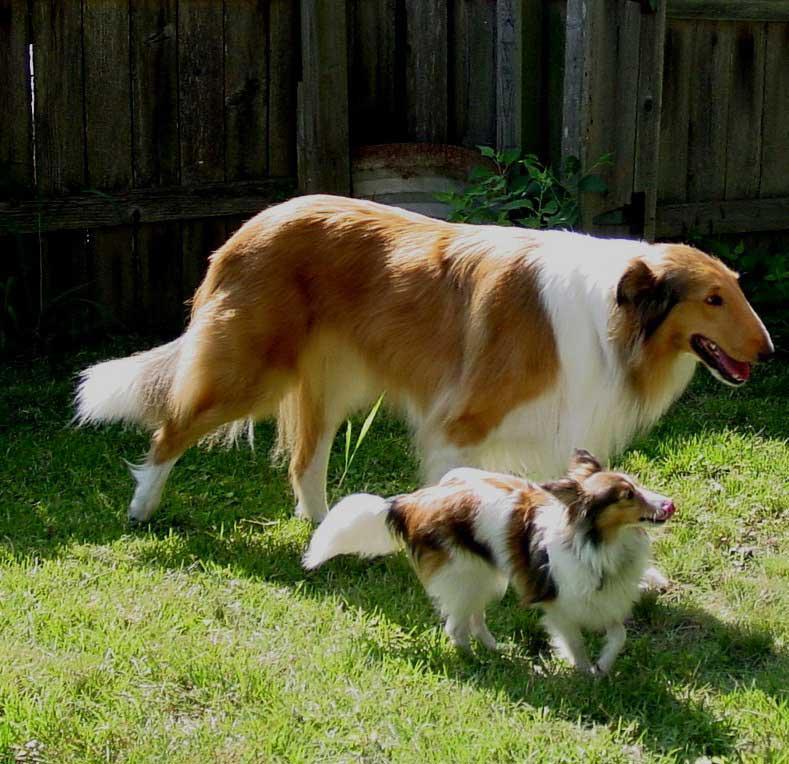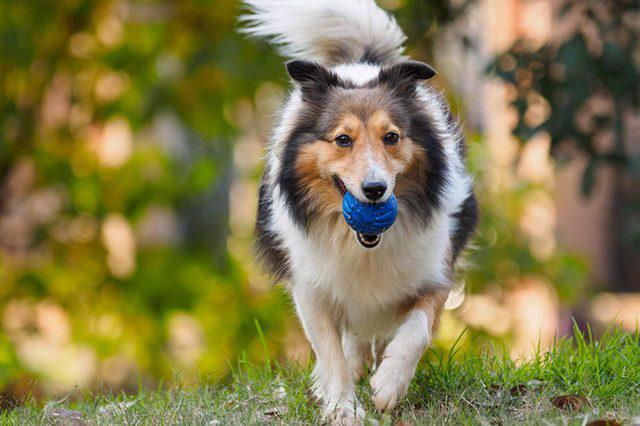The first image is the image on the left, the second image is the image on the right. For the images displayed, is the sentence "An image shows a young pup sitting on a cut stump." factually correct? Answer yes or no. No. 